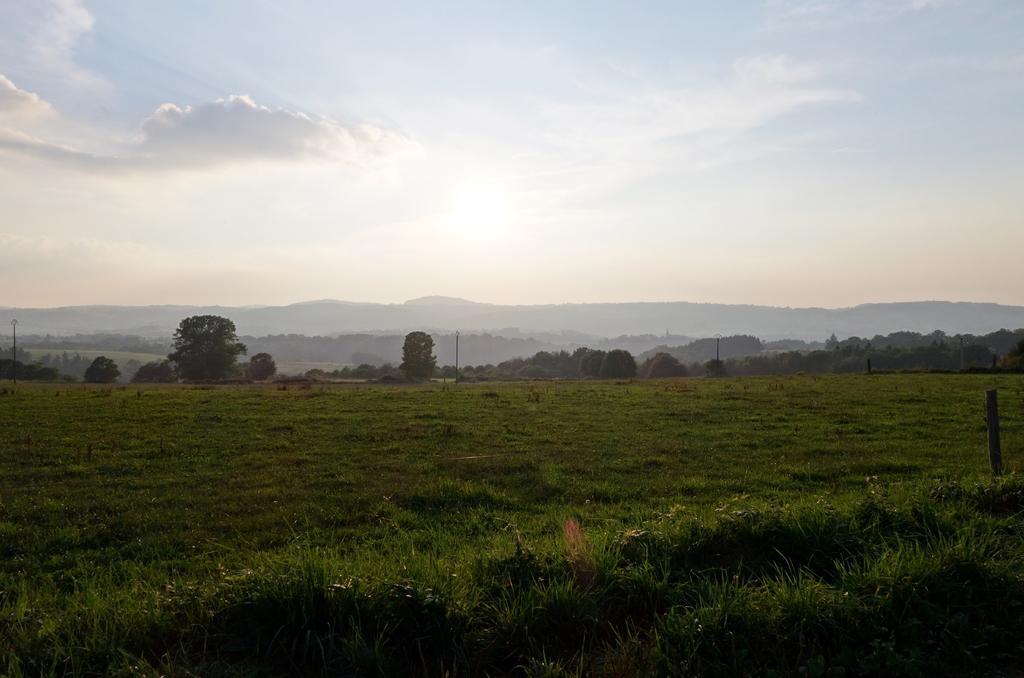Describe this image in one or two sentences. In this image, there are trees, grass, poles and hills. In the background, there is the sky. 